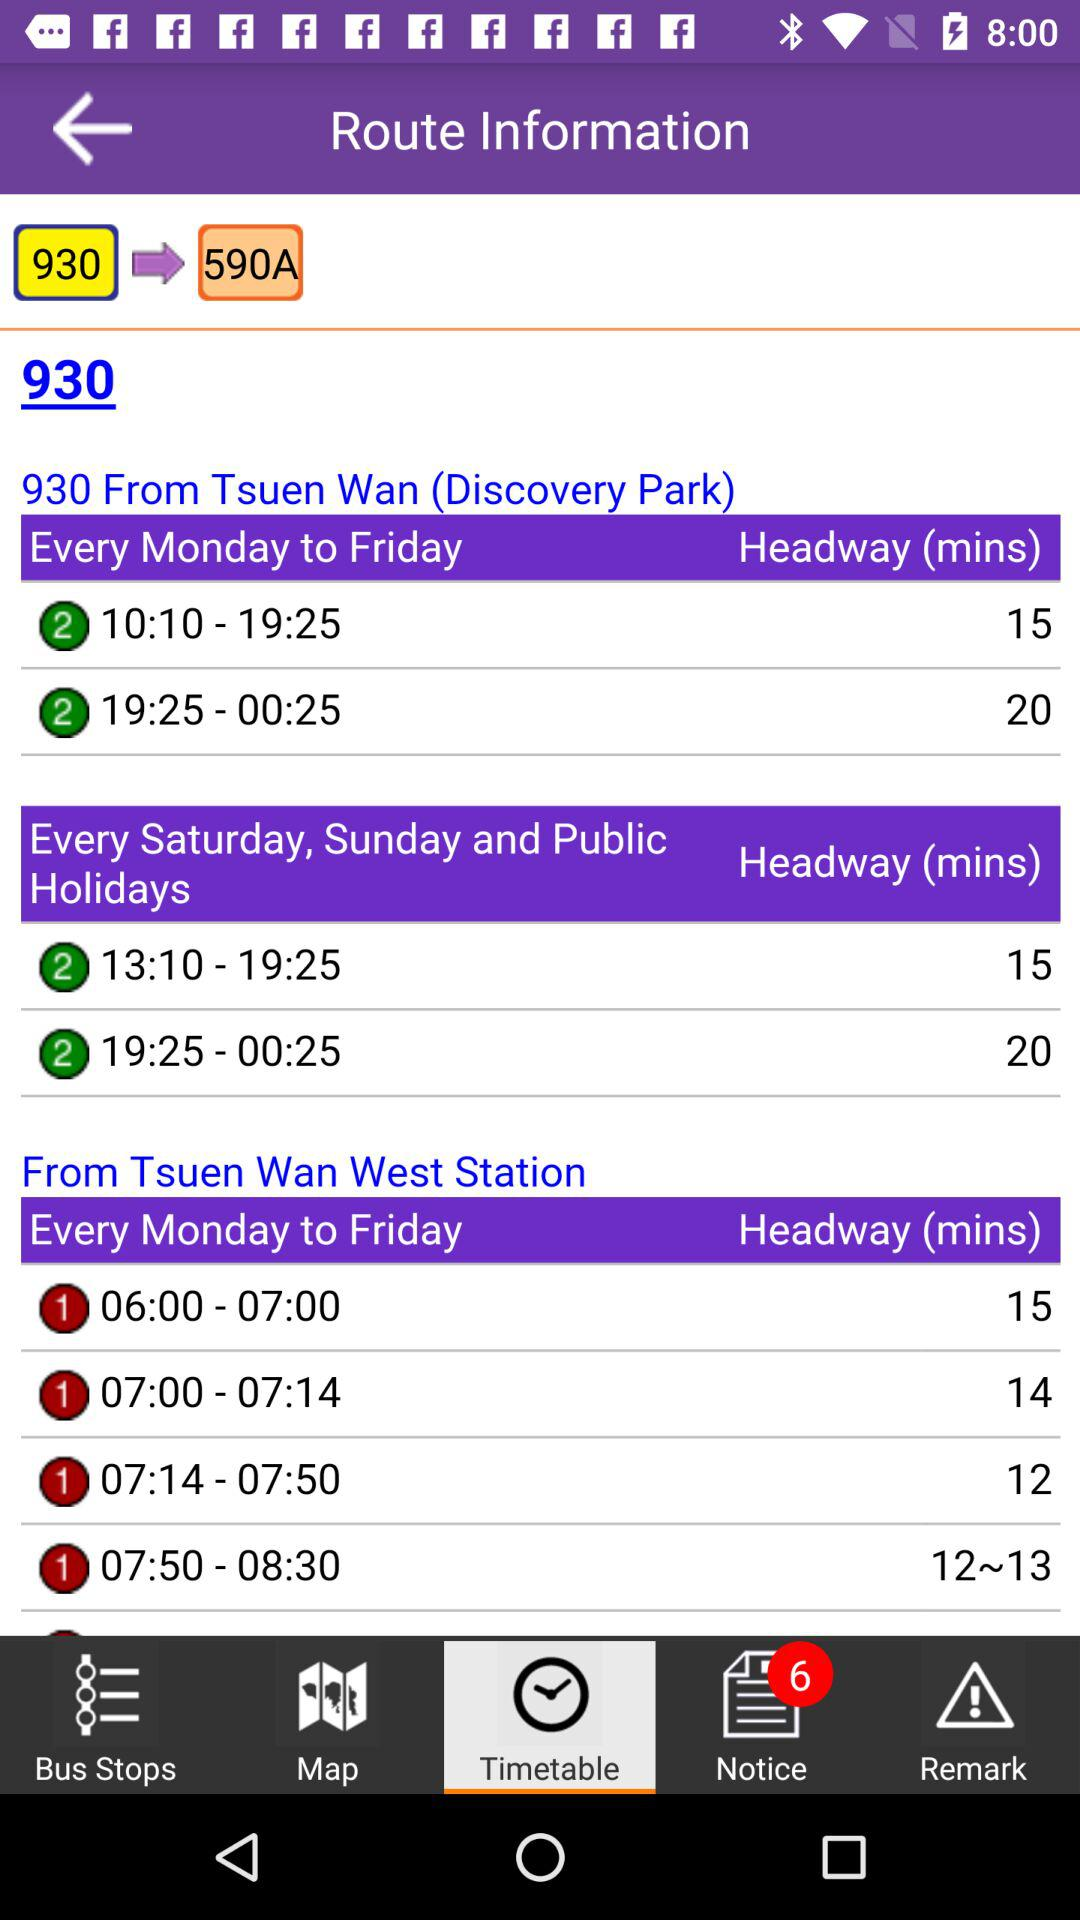How many unread notices are there? There are 6 unread notices. 